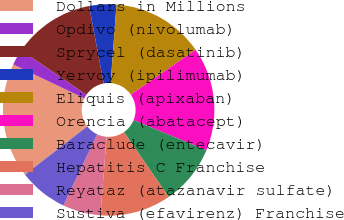Convert chart to OTSL. <chart><loc_0><loc_0><loc_500><loc_500><pie_chart><fcel>Dollars in Millions<fcel>Opdivo (nivolumab)<fcel>Sprycel (dasatinib)<fcel>Yervoy (ipilimumab)<fcel>Eliquis (apixaban)<fcel>Orencia (abatacept)<fcel>Baraclude (entecavir)<fcel>Hepatitis C Franchise<fcel>Reyataz (atazanavir sulfate)<fcel>Sustiva (efavirenz) Franchise<nl><fcel>17.54%<fcel>2.46%<fcel>12.51%<fcel>4.14%<fcel>14.19%<fcel>15.86%<fcel>9.16%<fcel>10.84%<fcel>5.81%<fcel>7.49%<nl></chart> 